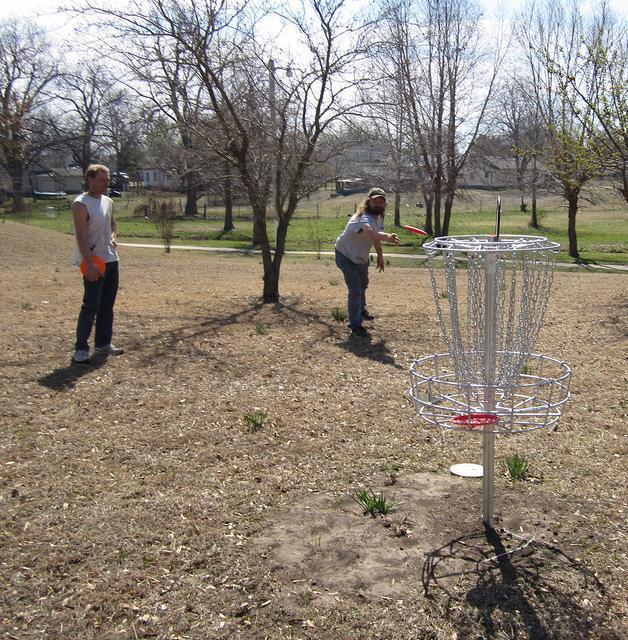How many men do you see?
Give a very brief answer. 2. How many people can be seen?
Give a very brief answer. 2. 